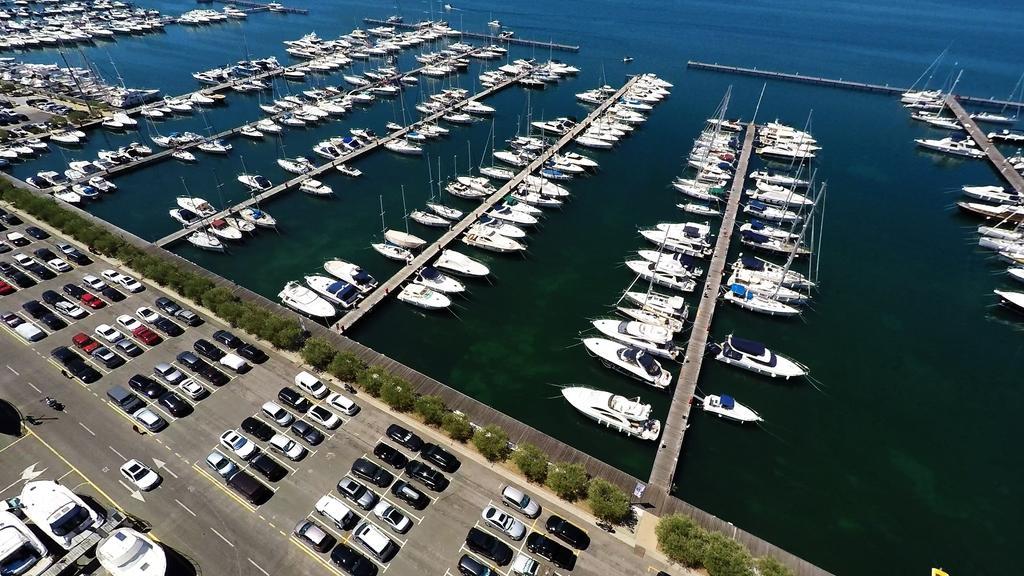Can you describe this image briefly? In this image we can see a fleet and decks on water, a group of trees and in the background, we can see a group of cars parked in the parking lot. 